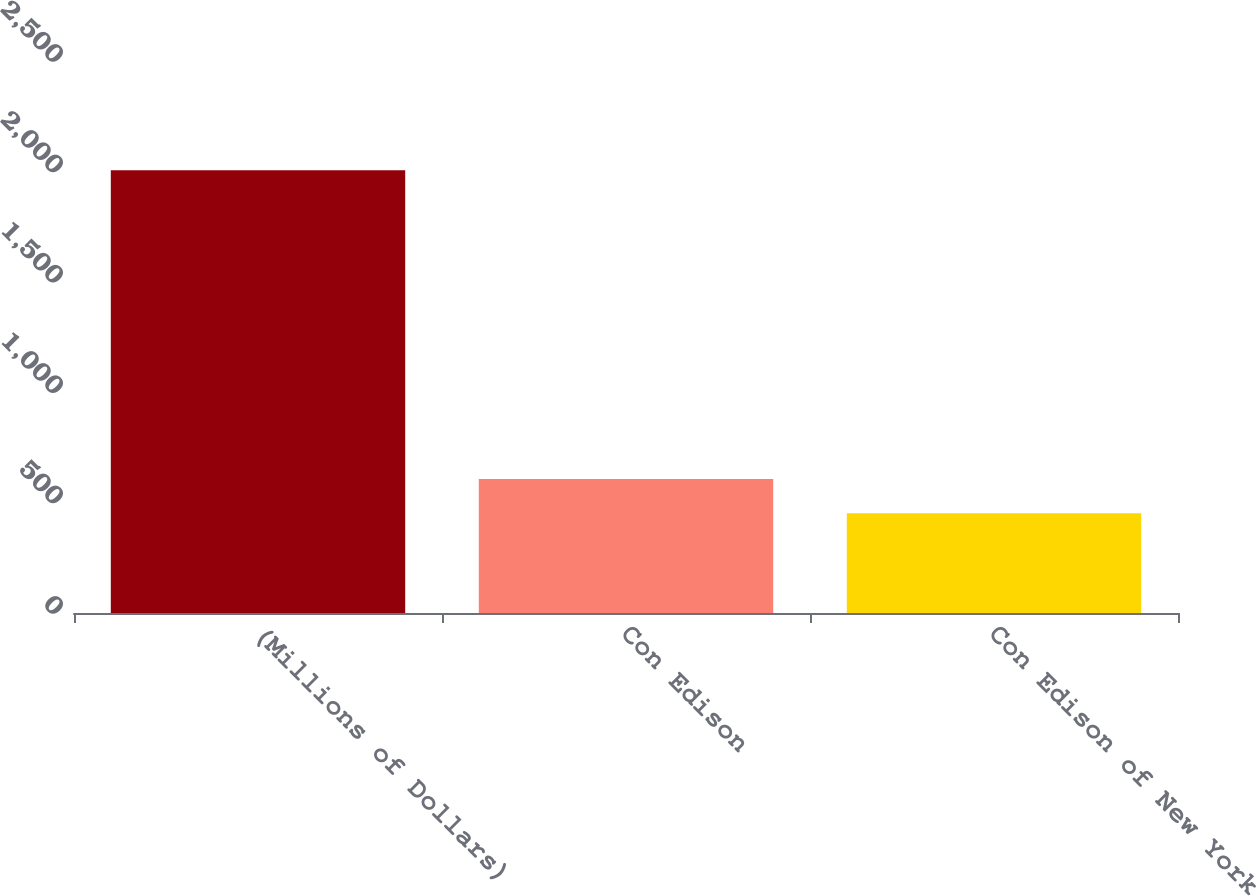Convert chart. <chart><loc_0><loc_0><loc_500><loc_500><bar_chart><fcel>(Millions of Dollars)<fcel>Con Edison<fcel>Con Edison of New York<nl><fcel>2005<fcel>607.3<fcel>452<nl></chart> 